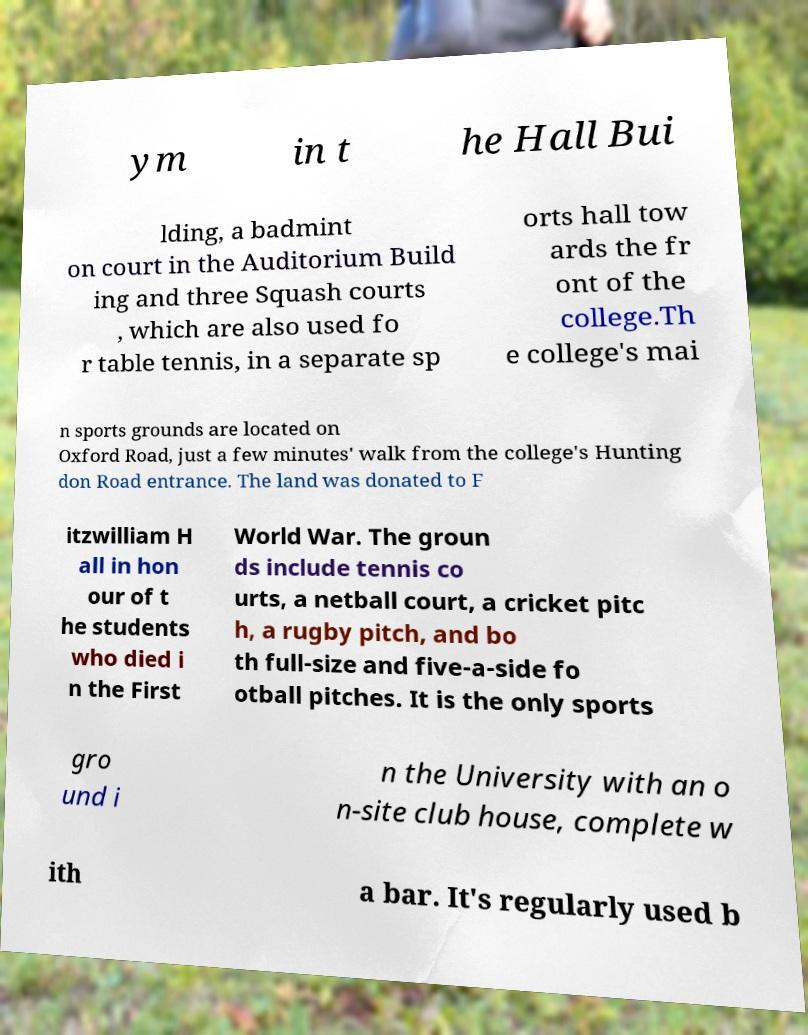Can you read and provide the text displayed in the image?This photo seems to have some interesting text. Can you extract and type it out for me? ym in t he Hall Bui lding, a badmint on court in the Auditorium Build ing and three Squash courts , which are also used fo r table tennis, in a separate sp orts hall tow ards the fr ont of the college.Th e college's mai n sports grounds are located on Oxford Road, just a few minutes' walk from the college's Hunting don Road entrance. The land was donated to F itzwilliam H all in hon our of t he students who died i n the First World War. The groun ds include tennis co urts, a netball court, a cricket pitc h, a rugby pitch, and bo th full-size and five-a-side fo otball pitches. It is the only sports gro und i n the University with an o n-site club house, complete w ith a bar. It's regularly used b 